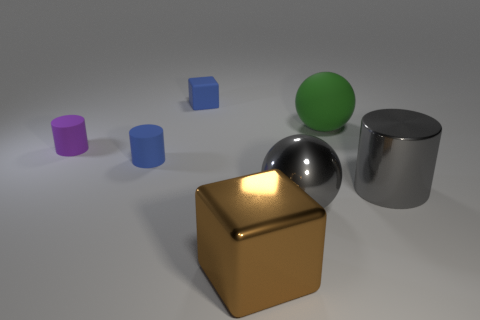Add 2 small blue things. How many objects exist? 9 Subtract all cubes. How many objects are left? 5 Add 6 yellow cubes. How many yellow cubes exist? 6 Subtract 0 cyan cylinders. How many objects are left? 7 Subtract all green matte cylinders. Subtract all rubber cubes. How many objects are left? 6 Add 3 blue cylinders. How many blue cylinders are left? 4 